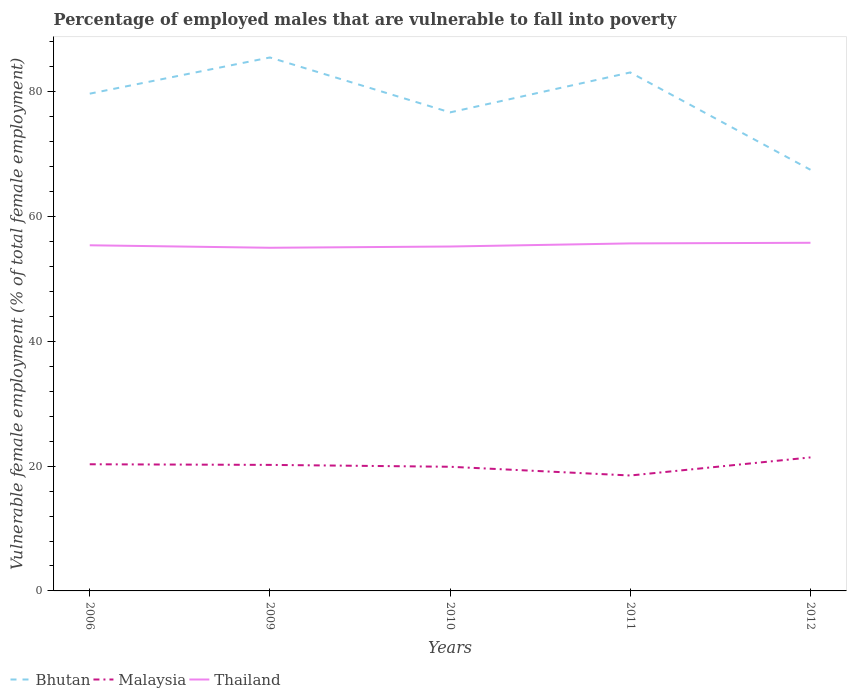How many different coloured lines are there?
Provide a succinct answer. 3. Across all years, what is the maximum percentage of employed males who are vulnerable to fall into poverty in Bhutan?
Keep it short and to the point. 67.5. What is the total percentage of employed males who are vulnerable to fall into poverty in Malaysia in the graph?
Give a very brief answer. 1.7. Is the percentage of employed males who are vulnerable to fall into poverty in Bhutan strictly greater than the percentage of employed males who are vulnerable to fall into poverty in Thailand over the years?
Provide a succinct answer. No. What is the difference between two consecutive major ticks on the Y-axis?
Provide a short and direct response. 20. Are the values on the major ticks of Y-axis written in scientific E-notation?
Your answer should be very brief. No. Does the graph contain any zero values?
Your response must be concise. No. Does the graph contain grids?
Your answer should be very brief. No. Where does the legend appear in the graph?
Offer a terse response. Bottom left. What is the title of the graph?
Give a very brief answer. Percentage of employed males that are vulnerable to fall into poverty. What is the label or title of the X-axis?
Ensure brevity in your answer.  Years. What is the label or title of the Y-axis?
Your answer should be very brief. Vulnerable female employment (% of total female employment). What is the Vulnerable female employment (% of total female employment) of Bhutan in 2006?
Give a very brief answer. 79.7. What is the Vulnerable female employment (% of total female employment) in Malaysia in 2006?
Offer a very short reply. 20.3. What is the Vulnerable female employment (% of total female employment) in Thailand in 2006?
Ensure brevity in your answer.  55.4. What is the Vulnerable female employment (% of total female employment) of Bhutan in 2009?
Provide a succinct answer. 85.5. What is the Vulnerable female employment (% of total female employment) of Malaysia in 2009?
Give a very brief answer. 20.2. What is the Vulnerable female employment (% of total female employment) in Bhutan in 2010?
Your answer should be very brief. 76.7. What is the Vulnerable female employment (% of total female employment) in Malaysia in 2010?
Make the answer very short. 19.9. What is the Vulnerable female employment (% of total female employment) of Thailand in 2010?
Offer a terse response. 55.2. What is the Vulnerable female employment (% of total female employment) in Bhutan in 2011?
Provide a succinct answer. 83.1. What is the Vulnerable female employment (% of total female employment) in Thailand in 2011?
Your answer should be compact. 55.7. What is the Vulnerable female employment (% of total female employment) in Bhutan in 2012?
Your answer should be very brief. 67.5. What is the Vulnerable female employment (% of total female employment) in Malaysia in 2012?
Offer a very short reply. 21.4. What is the Vulnerable female employment (% of total female employment) in Thailand in 2012?
Your response must be concise. 55.8. Across all years, what is the maximum Vulnerable female employment (% of total female employment) in Bhutan?
Your answer should be very brief. 85.5. Across all years, what is the maximum Vulnerable female employment (% of total female employment) in Malaysia?
Make the answer very short. 21.4. Across all years, what is the maximum Vulnerable female employment (% of total female employment) in Thailand?
Offer a terse response. 55.8. Across all years, what is the minimum Vulnerable female employment (% of total female employment) in Bhutan?
Keep it short and to the point. 67.5. Across all years, what is the minimum Vulnerable female employment (% of total female employment) in Thailand?
Offer a terse response. 55. What is the total Vulnerable female employment (% of total female employment) in Bhutan in the graph?
Your response must be concise. 392.5. What is the total Vulnerable female employment (% of total female employment) in Malaysia in the graph?
Your response must be concise. 100.3. What is the total Vulnerable female employment (% of total female employment) in Thailand in the graph?
Your answer should be very brief. 277.1. What is the difference between the Vulnerable female employment (% of total female employment) of Bhutan in 2006 and that in 2010?
Keep it short and to the point. 3. What is the difference between the Vulnerable female employment (% of total female employment) in Thailand in 2006 and that in 2010?
Provide a succinct answer. 0.2. What is the difference between the Vulnerable female employment (% of total female employment) of Bhutan in 2006 and that in 2011?
Provide a succinct answer. -3.4. What is the difference between the Vulnerable female employment (% of total female employment) of Thailand in 2006 and that in 2011?
Keep it short and to the point. -0.3. What is the difference between the Vulnerable female employment (% of total female employment) in Malaysia in 2009 and that in 2010?
Ensure brevity in your answer.  0.3. What is the difference between the Vulnerable female employment (% of total female employment) of Thailand in 2009 and that in 2010?
Provide a succinct answer. -0.2. What is the difference between the Vulnerable female employment (% of total female employment) in Bhutan in 2009 and that in 2011?
Provide a succinct answer. 2.4. What is the difference between the Vulnerable female employment (% of total female employment) in Malaysia in 2009 and that in 2011?
Provide a short and direct response. 1.7. What is the difference between the Vulnerable female employment (% of total female employment) in Thailand in 2009 and that in 2011?
Offer a terse response. -0.7. What is the difference between the Vulnerable female employment (% of total female employment) in Malaysia in 2009 and that in 2012?
Make the answer very short. -1.2. What is the difference between the Vulnerable female employment (% of total female employment) of Bhutan in 2010 and that in 2011?
Give a very brief answer. -6.4. What is the difference between the Vulnerable female employment (% of total female employment) of Malaysia in 2010 and that in 2011?
Provide a succinct answer. 1.4. What is the difference between the Vulnerable female employment (% of total female employment) of Thailand in 2010 and that in 2011?
Your response must be concise. -0.5. What is the difference between the Vulnerable female employment (% of total female employment) of Bhutan in 2010 and that in 2012?
Make the answer very short. 9.2. What is the difference between the Vulnerable female employment (% of total female employment) in Bhutan in 2011 and that in 2012?
Provide a succinct answer. 15.6. What is the difference between the Vulnerable female employment (% of total female employment) in Malaysia in 2011 and that in 2012?
Offer a very short reply. -2.9. What is the difference between the Vulnerable female employment (% of total female employment) of Thailand in 2011 and that in 2012?
Your answer should be compact. -0.1. What is the difference between the Vulnerable female employment (% of total female employment) in Bhutan in 2006 and the Vulnerable female employment (% of total female employment) in Malaysia in 2009?
Keep it short and to the point. 59.5. What is the difference between the Vulnerable female employment (% of total female employment) in Bhutan in 2006 and the Vulnerable female employment (% of total female employment) in Thailand in 2009?
Make the answer very short. 24.7. What is the difference between the Vulnerable female employment (% of total female employment) in Malaysia in 2006 and the Vulnerable female employment (% of total female employment) in Thailand in 2009?
Provide a succinct answer. -34.7. What is the difference between the Vulnerable female employment (% of total female employment) of Bhutan in 2006 and the Vulnerable female employment (% of total female employment) of Malaysia in 2010?
Your response must be concise. 59.8. What is the difference between the Vulnerable female employment (% of total female employment) in Bhutan in 2006 and the Vulnerable female employment (% of total female employment) in Thailand in 2010?
Your response must be concise. 24.5. What is the difference between the Vulnerable female employment (% of total female employment) in Malaysia in 2006 and the Vulnerable female employment (% of total female employment) in Thailand in 2010?
Your answer should be very brief. -34.9. What is the difference between the Vulnerable female employment (% of total female employment) of Bhutan in 2006 and the Vulnerable female employment (% of total female employment) of Malaysia in 2011?
Keep it short and to the point. 61.2. What is the difference between the Vulnerable female employment (% of total female employment) of Malaysia in 2006 and the Vulnerable female employment (% of total female employment) of Thailand in 2011?
Offer a very short reply. -35.4. What is the difference between the Vulnerable female employment (% of total female employment) of Bhutan in 2006 and the Vulnerable female employment (% of total female employment) of Malaysia in 2012?
Offer a terse response. 58.3. What is the difference between the Vulnerable female employment (% of total female employment) in Bhutan in 2006 and the Vulnerable female employment (% of total female employment) in Thailand in 2012?
Offer a very short reply. 23.9. What is the difference between the Vulnerable female employment (% of total female employment) of Malaysia in 2006 and the Vulnerable female employment (% of total female employment) of Thailand in 2012?
Ensure brevity in your answer.  -35.5. What is the difference between the Vulnerable female employment (% of total female employment) of Bhutan in 2009 and the Vulnerable female employment (% of total female employment) of Malaysia in 2010?
Give a very brief answer. 65.6. What is the difference between the Vulnerable female employment (% of total female employment) of Bhutan in 2009 and the Vulnerable female employment (% of total female employment) of Thailand in 2010?
Keep it short and to the point. 30.3. What is the difference between the Vulnerable female employment (% of total female employment) in Malaysia in 2009 and the Vulnerable female employment (% of total female employment) in Thailand in 2010?
Offer a terse response. -35. What is the difference between the Vulnerable female employment (% of total female employment) of Bhutan in 2009 and the Vulnerable female employment (% of total female employment) of Malaysia in 2011?
Make the answer very short. 67. What is the difference between the Vulnerable female employment (% of total female employment) in Bhutan in 2009 and the Vulnerable female employment (% of total female employment) in Thailand in 2011?
Make the answer very short. 29.8. What is the difference between the Vulnerable female employment (% of total female employment) in Malaysia in 2009 and the Vulnerable female employment (% of total female employment) in Thailand in 2011?
Provide a succinct answer. -35.5. What is the difference between the Vulnerable female employment (% of total female employment) of Bhutan in 2009 and the Vulnerable female employment (% of total female employment) of Malaysia in 2012?
Provide a short and direct response. 64.1. What is the difference between the Vulnerable female employment (% of total female employment) in Bhutan in 2009 and the Vulnerable female employment (% of total female employment) in Thailand in 2012?
Offer a terse response. 29.7. What is the difference between the Vulnerable female employment (% of total female employment) in Malaysia in 2009 and the Vulnerable female employment (% of total female employment) in Thailand in 2012?
Ensure brevity in your answer.  -35.6. What is the difference between the Vulnerable female employment (% of total female employment) in Bhutan in 2010 and the Vulnerable female employment (% of total female employment) in Malaysia in 2011?
Make the answer very short. 58.2. What is the difference between the Vulnerable female employment (% of total female employment) in Bhutan in 2010 and the Vulnerable female employment (% of total female employment) in Thailand in 2011?
Offer a very short reply. 21. What is the difference between the Vulnerable female employment (% of total female employment) in Malaysia in 2010 and the Vulnerable female employment (% of total female employment) in Thailand in 2011?
Make the answer very short. -35.8. What is the difference between the Vulnerable female employment (% of total female employment) of Bhutan in 2010 and the Vulnerable female employment (% of total female employment) of Malaysia in 2012?
Make the answer very short. 55.3. What is the difference between the Vulnerable female employment (% of total female employment) in Bhutan in 2010 and the Vulnerable female employment (% of total female employment) in Thailand in 2012?
Your answer should be very brief. 20.9. What is the difference between the Vulnerable female employment (% of total female employment) in Malaysia in 2010 and the Vulnerable female employment (% of total female employment) in Thailand in 2012?
Offer a very short reply. -35.9. What is the difference between the Vulnerable female employment (% of total female employment) of Bhutan in 2011 and the Vulnerable female employment (% of total female employment) of Malaysia in 2012?
Your answer should be compact. 61.7. What is the difference between the Vulnerable female employment (% of total female employment) in Bhutan in 2011 and the Vulnerable female employment (% of total female employment) in Thailand in 2012?
Keep it short and to the point. 27.3. What is the difference between the Vulnerable female employment (% of total female employment) in Malaysia in 2011 and the Vulnerable female employment (% of total female employment) in Thailand in 2012?
Provide a short and direct response. -37.3. What is the average Vulnerable female employment (% of total female employment) in Bhutan per year?
Offer a terse response. 78.5. What is the average Vulnerable female employment (% of total female employment) in Malaysia per year?
Give a very brief answer. 20.06. What is the average Vulnerable female employment (% of total female employment) in Thailand per year?
Give a very brief answer. 55.42. In the year 2006, what is the difference between the Vulnerable female employment (% of total female employment) in Bhutan and Vulnerable female employment (% of total female employment) in Malaysia?
Make the answer very short. 59.4. In the year 2006, what is the difference between the Vulnerable female employment (% of total female employment) of Bhutan and Vulnerable female employment (% of total female employment) of Thailand?
Give a very brief answer. 24.3. In the year 2006, what is the difference between the Vulnerable female employment (% of total female employment) in Malaysia and Vulnerable female employment (% of total female employment) in Thailand?
Your response must be concise. -35.1. In the year 2009, what is the difference between the Vulnerable female employment (% of total female employment) of Bhutan and Vulnerable female employment (% of total female employment) of Malaysia?
Provide a short and direct response. 65.3. In the year 2009, what is the difference between the Vulnerable female employment (% of total female employment) of Bhutan and Vulnerable female employment (% of total female employment) of Thailand?
Provide a short and direct response. 30.5. In the year 2009, what is the difference between the Vulnerable female employment (% of total female employment) of Malaysia and Vulnerable female employment (% of total female employment) of Thailand?
Make the answer very short. -34.8. In the year 2010, what is the difference between the Vulnerable female employment (% of total female employment) in Bhutan and Vulnerable female employment (% of total female employment) in Malaysia?
Give a very brief answer. 56.8. In the year 2010, what is the difference between the Vulnerable female employment (% of total female employment) in Bhutan and Vulnerable female employment (% of total female employment) in Thailand?
Your response must be concise. 21.5. In the year 2010, what is the difference between the Vulnerable female employment (% of total female employment) in Malaysia and Vulnerable female employment (% of total female employment) in Thailand?
Provide a short and direct response. -35.3. In the year 2011, what is the difference between the Vulnerable female employment (% of total female employment) of Bhutan and Vulnerable female employment (% of total female employment) of Malaysia?
Provide a succinct answer. 64.6. In the year 2011, what is the difference between the Vulnerable female employment (% of total female employment) in Bhutan and Vulnerable female employment (% of total female employment) in Thailand?
Your answer should be compact. 27.4. In the year 2011, what is the difference between the Vulnerable female employment (% of total female employment) in Malaysia and Vulnerable female employment (% of total female employment) in Thailand?
Give a very brief answer. -37.2. In the year 2012, what is the difference between the Vulnerable female employment (% of total female employment) in Bhutan and Vulnerable female employment (% of total female employment) in Malaysia?
Your answer should be compact. 46.1. In the year 2012, what is the difference between the Vulnerable female employment (% of total female employment) of Malaysia and Vulnerable female employment (% of total female employment) of Thailand?
Give a very brief answer. -34.4. What is the ratio of the Vulnerable female employment (% of total female employment) of Bhutan in 2006 to that in 2009?
Make the answer very short. 0.93. What is the ratio of the Vulnerable female employment (% of total female employment) of Malaysia in 2006 to that in 2009?
Your answer should be very brief. 1. What is the ratio of the Vulnerable female employment (% of total female employment) in Thailand in 2006 to that in 2009?
Your response must be concise. 1.01. What is the ratio of the Vulnerable female employment (% of total female employment) of Bhutan in 2006 to that in 2010?
Provide a short and direct response. 1.04. What is the ratio of the Vulnerable female employment (% of total female employment) of Malaysia in 2006 to that in 2010?
Offer a very short reply. 1.02. What is the ratio of the Vulnerable female employment (% of total female employment) in Thailand in 2006 to that in 2010?
Keep it short and to the point. 1. What is the ratio of the Vulnerable female employment (% of total female employment) in Bhutan in 2006 to that in 2011?
Make the answer very short. 0.96. What is the ratio of the Vulnerable female employment (% of total female employment) in Malaysia in 2006 to that in 2011?
Offer a very short reply. 1.1. What is the ratio of the Vulnerable female employment (% of total female employment) in Bhutan in 2006 to that in 2012?
Your response must be concise. 1.18. What is the ratio of the Vulnerable female employment (% of total female employment) of Malaysia in 2006 to that in 2012?
Keep it short and to the point. 0.95. What is the ratio of the Vulnerable female employment (% of total female employment) of Thailand in 2006 to that in 2012?
Offer a very short reply. 0.99. What is the ratio of the Vulnerable female employment (% of total female employment) in Bhutan in 2009 to that in 2010?
Provide a short and direct response. 1.11. What is the ratio of the Vulnerable female employment (% of total female employment) of Malaysia in 2009 to that in 2010?
Ensure brevity in your answer.  1.02. What is the ratio of the Vulnerable female employment (% of total female employment) in Bhutan in 2009 to that in 2011?
Ensure brevity in your answer.  1.03. What is the ratio of the Vulnerable female employment (% of total female employment) of Malaysia in 2009 to that in 2011?
Ensure brevity in your answer.  1.09. What is the ratio of the Vulnerable female employment (% of total female employment) in Thailand in 2009 to that in 2011?
Offer a very short reply. 0.99. What is the ratio of the Vulnerable female employment (% of total female employment) in Bhutan in 2009 to that in 2012?
Ensure brevity in your answer.  1.27. What is the ratio of the Vulnerable female employment (% of total female employment) of Malaysia in 2009 to that in 2012?
Your answer should be very brief. 0.94. What is the ratio of the Vulnerable female employment (% of total female employment) of Thailand in 2009 to that in 2012?
Provide a succinct answer. 0.99. What is the ratio of the Vulnerable female employment (% of total female employment) of Bhutan in 2010 to that in 2011?
Your answer should be compact. 0.92. What is the ratio of the Vulnerable female employment (% of total female employment) in Malaysia in 2010 to that in 2011?
Keep it short and to the point. 1.08. What is the ratio of the Vulnerable female employment (% of total female employment) of Thailand in 2010 to that in 2011?
Provide a short and direct response. 0.99. What is the ratio of the Vulnerable female employment (% of total female employment) in Bhutan in 2010 to that in 2012?
Offer a very short reply. 1.14. What is the ratio of the Vulnerable female employment (% of total female employment) in Malaysia in 2010 to that in 2012?
Ensure brevity in your answer.  0.93. What is the ratio of the Vulnerable female employment (% of total female employment) in Bhutan in 2011 to that in 2012?
Give a very brief answer. 1.23. What is the ratio of the Vulnerable female employment (% of total female employment) of Malaysia in 2011 to that in 2012?
Provide a short and direct response. 0.86. 